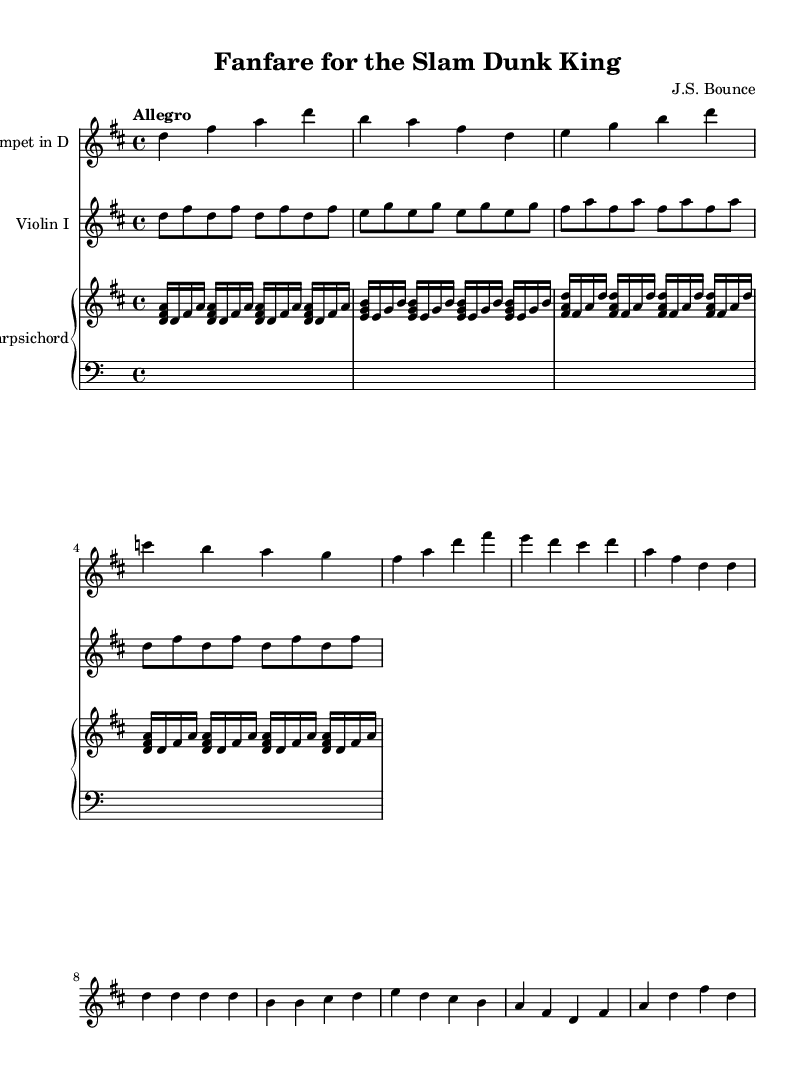What is the key signature of this music? The key signature shown at the beginning of the music indicates D major, which has two sharps (F# and C#). This can be identified by the sharp symbols placed on the staff lines.
Answer: D major What is the time signature of the piece? The time signature present in the music is 4/4, as indicated at the beginning. This means there are four beats in each measure and a quarter note receives one beat.
Answer: 4/4 What is the tempo marking for this piece? The tempo marking "Allegro" suggests a fast and lively pace. This marking is typically written above the staff and indicates the character of the performance.
Answer: Allegro What are the instruments featured in this score? The score features a trumpet, violin, and harpsichord. This can be discerned from the respective staves labeled at the beginning of each section of the music.
Answer: Trumpet, Violin, Harpsichord How many measures are in the A section of the piece? Counting each group of notes divided by the vertical bar lines indicates there are 8 measures in the A section, as it contains specific phrases separated accordingly.
Answer: 8 What unique characteristic of the trumpet part makes it reminiscent of stadium fanfares? The bold, melodic lines in the trumpet part, combined with its rhythmic accents, create a celebratory and triumphant sound often associated with fanfares heard in stadiums. This is highlighted by the frequent use of strong, clear pitches.
Answer: Bold, melodic lines What form does this piece primarily follow, suggesting a typical Baroque structure? The piece primarily follows a binary form, as evidenced by the distinct A and B sections that exhibit contrasting musical ideas, a characteristic structure often found in Baroque concertos.
Answer: Binary form 